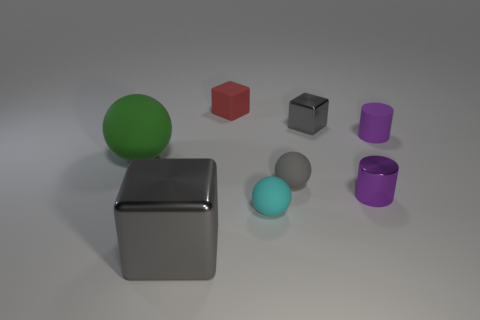How many other things are the same size as the green rubber sphere?
Make the answer very short. 1. What size is the other cylinder that is the same color as the tiny shiny cylinder?
Provide a short and direct response. Small. How many balls are green metal objects or small rubber things?
Provide a succinct answer. 2. There is a green object to the left of the tiny gray rubber ball; is it the same shape as the cyan thing?
Your answer should be very brief. Yes. Are there more red matte blocks behind the big green sphere than tiny yellow objects?
Ensure brevity in your answer.  Yes. There is another cylinder that is the same size as the purple rubber cylinder; what color is it?
Provide a succinct answer. Purple. How many objects are rubber things in front of the tiny purple shiny thing or large gray cylinders?
Your response must be concise. 1. There is a small shiny thing that is the same color as the rubber cylinder; what is its shape?
Provide a succinct answer. Cylinder. What material is the object behind the gray metallic block to the right of the small red block made of?
Keep it short and to the point. Rubber. Is there a purple object made of the same material as the large gray block?
Provide a short and direct response. Yes. 